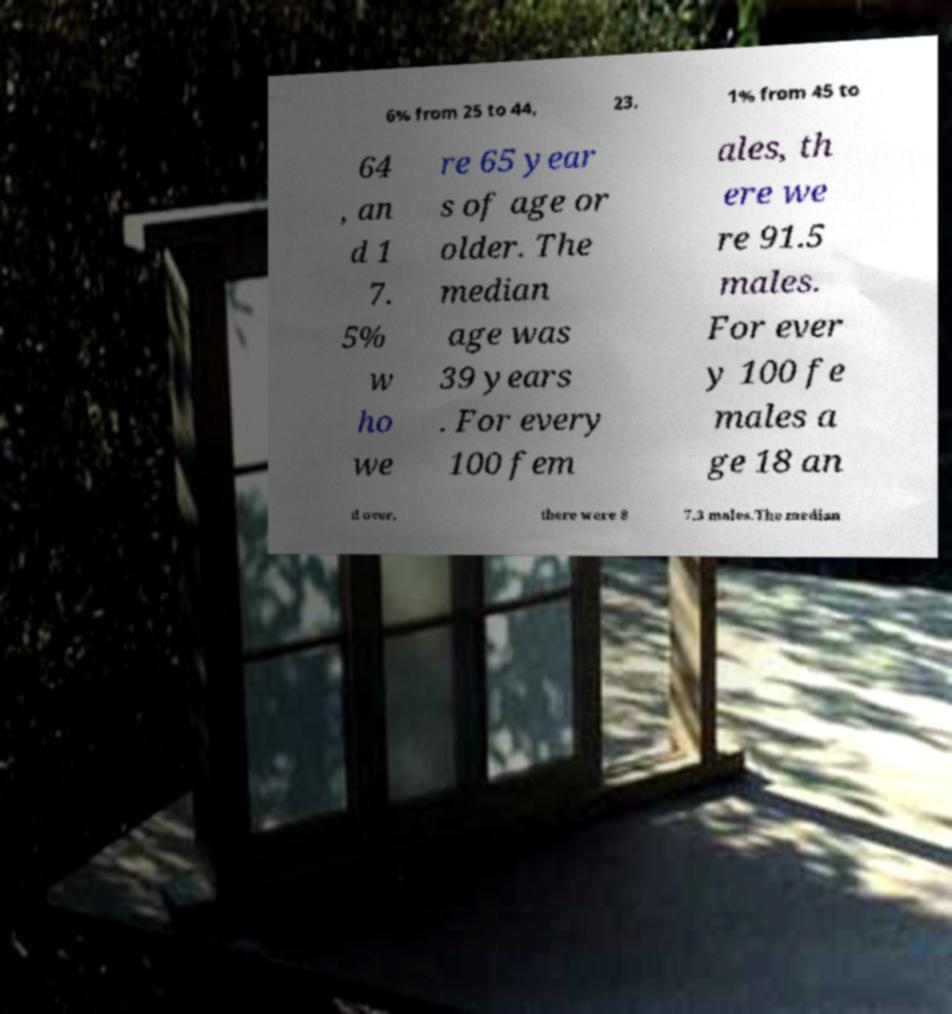Please read and relay the text visible in this image. What does it say? 6% from 25 to 44, 23. 1% from 45 to 64 , an d 1 7. 5% w ho we re 65 year s of age or older. The median age was 39 years . For every 100 fem ales, th ere we re 91.5 males. For ever y 100 fe males a ge 18 an d over, there were 8 7.3 males.The median 